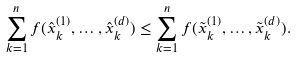<formula> <loc_0><loc_0><loc_500><loc_500>\sum _ { k = 1 } ^ { n } f ( \hat { x } ^ { ( 1 ) } _ { k } , \dots , \hat { x } ^ { ( d ) } _ { k } ) \leq \sum _ { k = 1 } ^ { n } f ( \tilde { x } ^ { ( 1 ) } _ { k } , \dots , \tilde { x } ^ { ( d ) } _ { k } ) .</formula> 